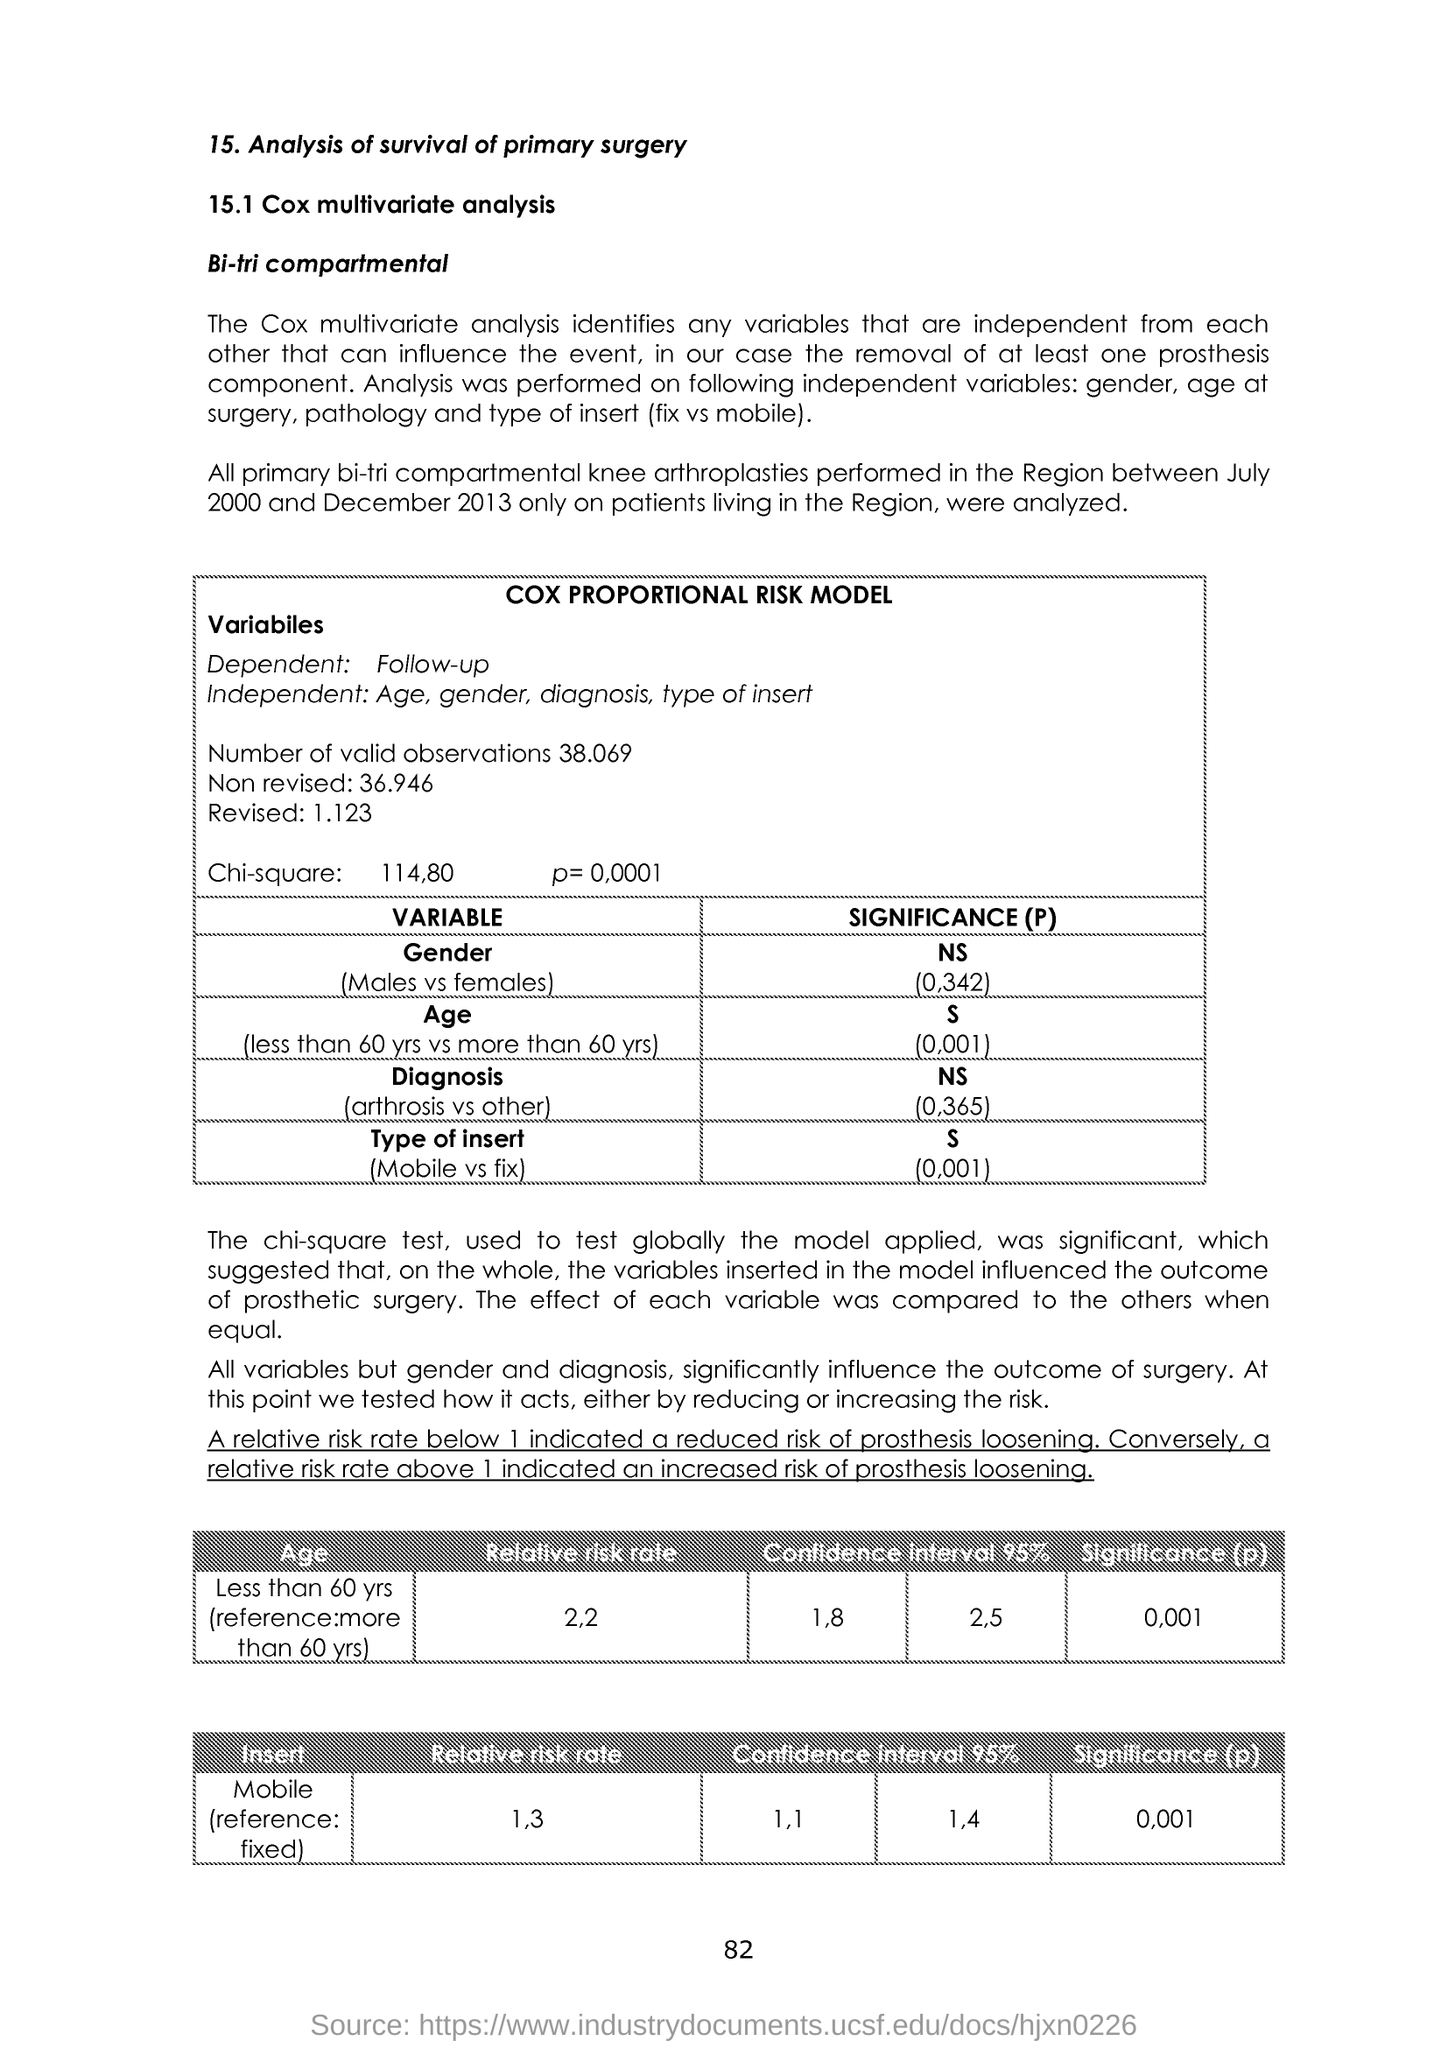Indicate a few pertinent items in this graphic. The relative risk rate in individuals under the age of 60 was 2.2. The dependent variable is the outcome or response that is being measured in a scientific study, and it is typically determined by the researcher and is not determined by the participant. A follow-up question to determine the dependent variable is to ask the researcher what they are trying to measure or observe in the study. The chi-square value is given as 114.80. There are 38.069... valid observations in the dataset. The significance level of the Mobile Insertion test was 0.001, which means that there is less than a 1% chance that the observed difference in the means of the two groups is due to chance. 